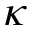Convert formula to latex. <formula><loc_0><loc_0><loc_500><loc_500>\kappa</formula> 